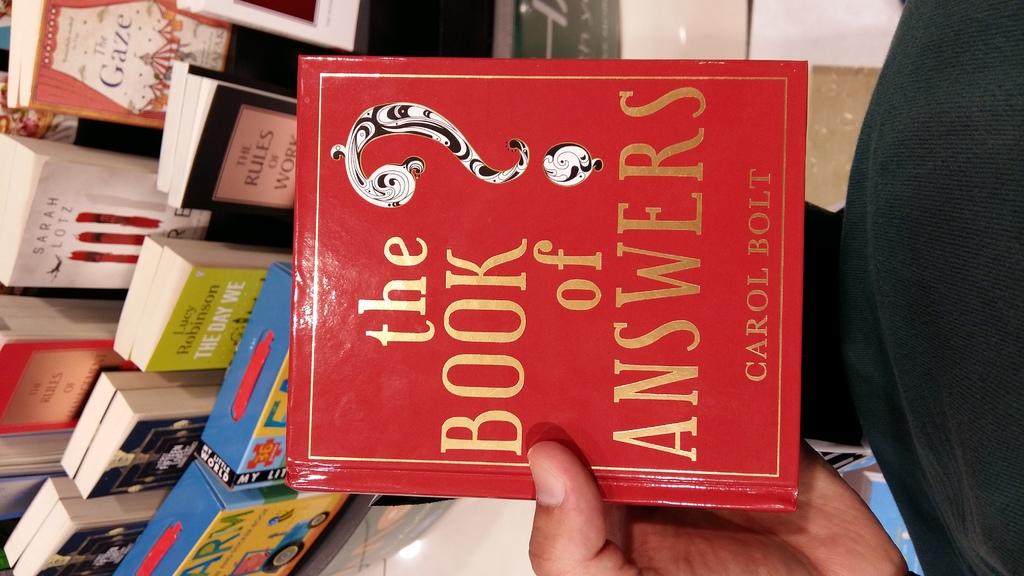Who is the author?
Provide a succinct answer. Carol bolt. 